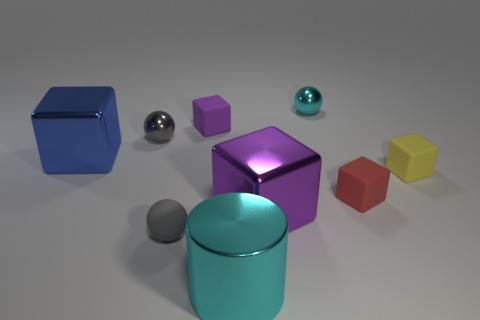The cyan object in front of the tiny matte object behind the big shiny thing left of the small gray metallic object is what shape?
Ensure brevity in your answer.  Cylinder. Is there any other thing that is the same shape as the big purple metal object?
Offer a very short reply. Yes. What number of spheres are either red objects or tiny gray matte objects?
Your answer should be compact. 1. Do the small shiny thing that is on the left side of the tiny cyan ball and the tiny matte sphere have the same color?
Offer a very short reply. Yes. The gray thing that is behind the large metal cube that is left of the ball in front of the big purple metallic object is made of what material?
Ensure brevity in your answer.  Metal. Is the cyan sphere the same size as the cylinder?
Provide a short and direct response. No. Is the color of the large metal cylinder the same as the small metallic object that is on the right side of the cylinder?
Give a very brief answer. Yes. There is a large cyan thing that is the same material as the blue object; what shape is it?
Ensure brevity in your answer.  Cylinder. Do the cyan shiny object that is to the right of the big cyan thing and the yellow thing have the same shape?
Ensure brevity in your answer.  No. There is a shiny ball to the left of the object behind the purple matte object; what is its size?
Provide a short and direct response. Small. 